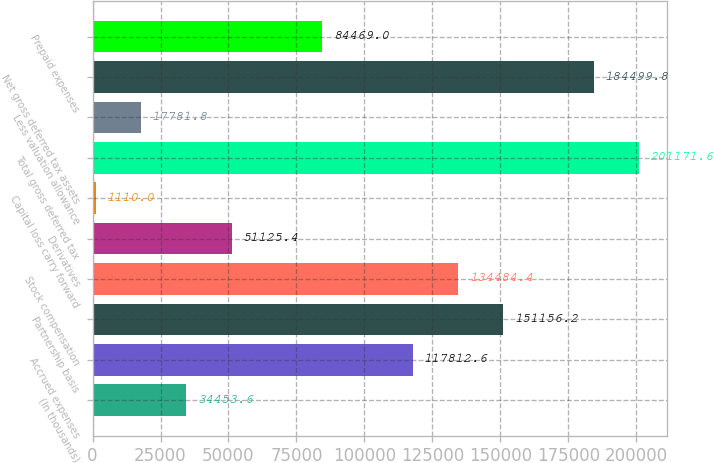Convert chart to OTSL. <chart><loc_0><loc_0><loc_500><loc_500><bar_chart><fcel>(In thousands)<fcel>Accrued expenses<fcel>Partnership basis<fcel>Stock compensation<fcel>Derivatives<fcel>Capital loss carry forward<fcel>Total gross deferred tax<fcel>Less valuation allowance<fcel>Net gross deferred tax assets<fcel>Prepaid expenses<nl><fcel>34453.6<fcel>117813<fcel>151156<fcel>134484<fcel>51125.4<fcel>1110<fcel>201172<fcel>17781.8<fcel>184500<fcel>84469<nl></chart> 